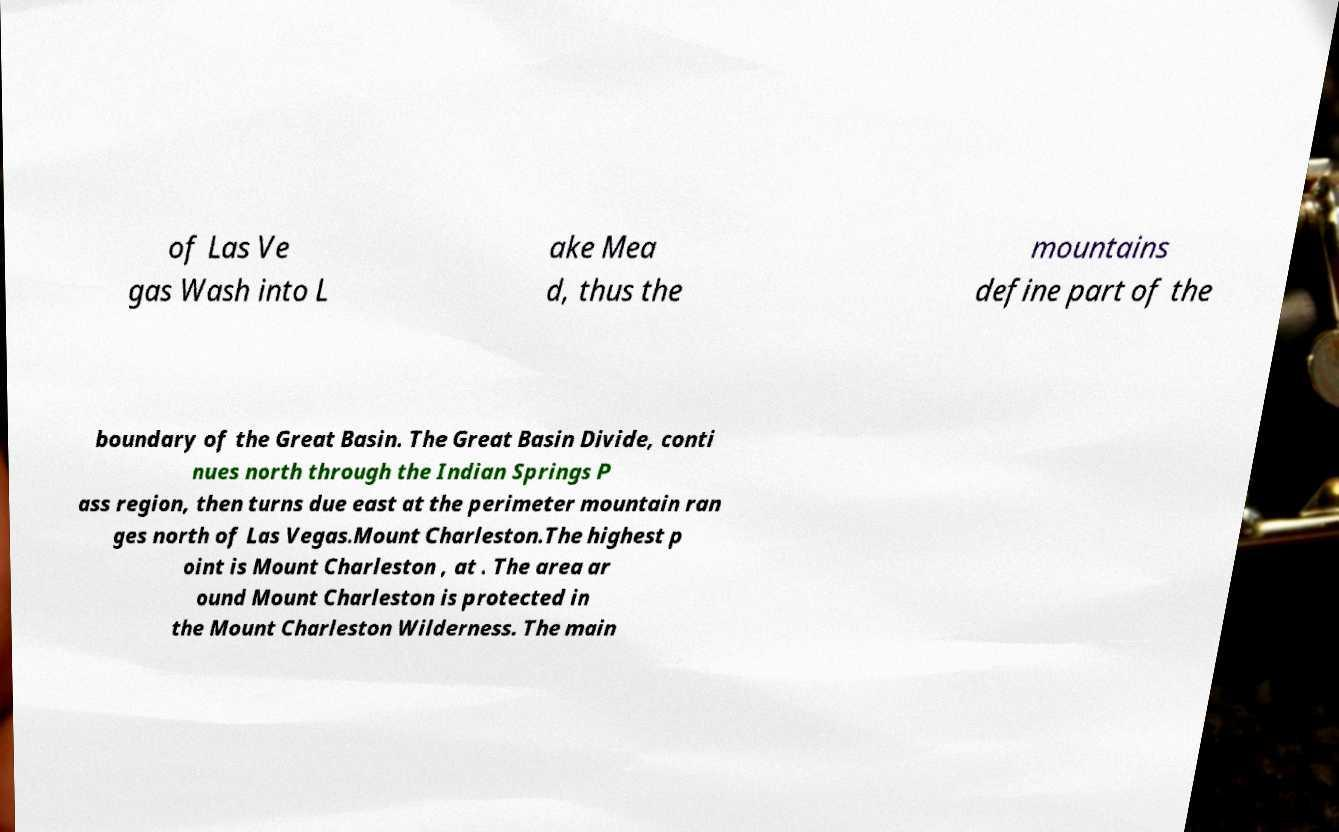What messages or text are displayed in this image? I need them in a readable, typed format. of Las Ve gas Wash into L ake Mea d, thus the mountains define part of the boundary of the Great Basin. The Great Basin Divide, conti nues north through the Indian Springs P ass region, then turns due east at the perimeter mountain ran ges north of Las Vegas.Mount Charleston.The highest p oint is Mount Charleston , at . The area ar ound Mount Charleston is protected in the Mount Charleston Wilderness. The main 